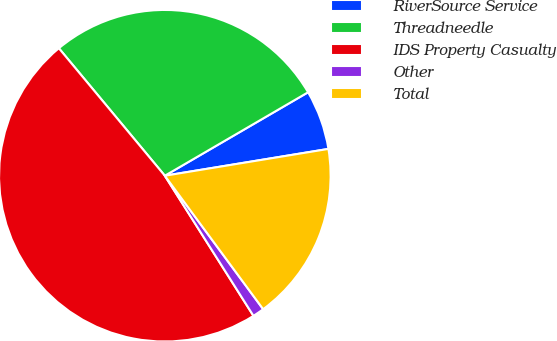Convert chart to OTSL. <chart><loc_0><loc_0><loc_500><loc_500><pie_chart><fcel>RiverSource Service<fcel>Threadneedle<fcel>IDS Property Casualty<fcel>Other<fcel>Total<nl><fcel>5.81%<fcel>27.64%<fcel>47.94%<fcel>1.13%<fcel>17.48%<nl></chart> 